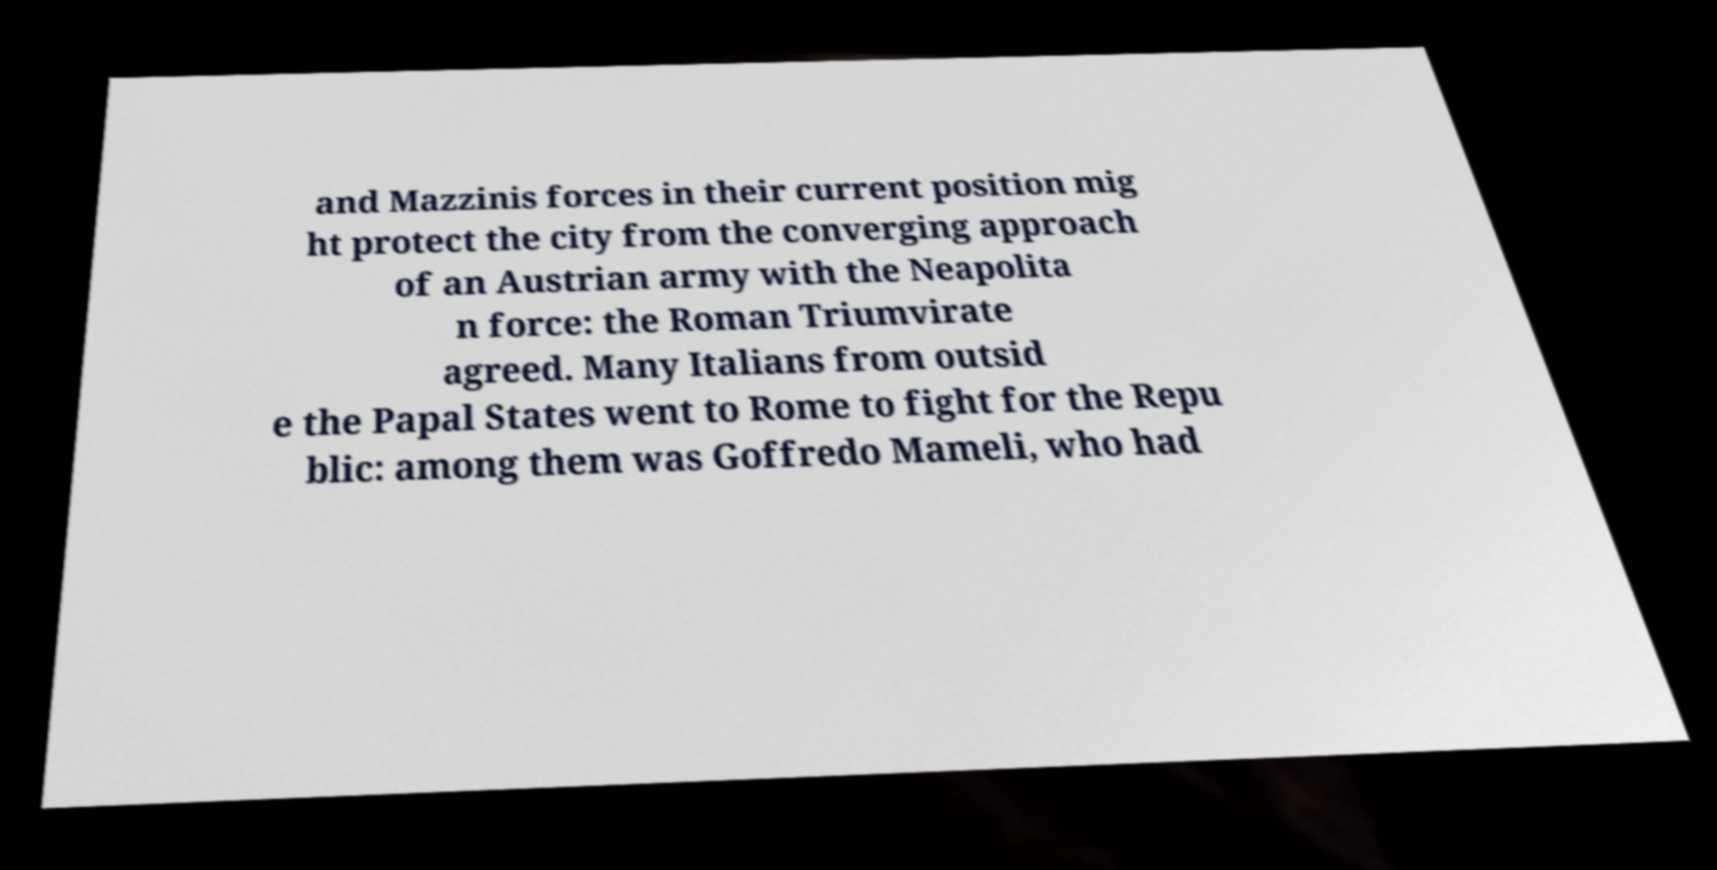Could you assist in decoding the text presented in this image and type it out clearly? and Mazzinis forces in their current position mig ht protect the city from the converging approach of an Austrian army with the Neapolita n force: the Roman Triumvirate agreed. Many Italians from outsid e the Papal States went to Rome to fight for the Repu blic: among them was Goffredo Mameli, who had 